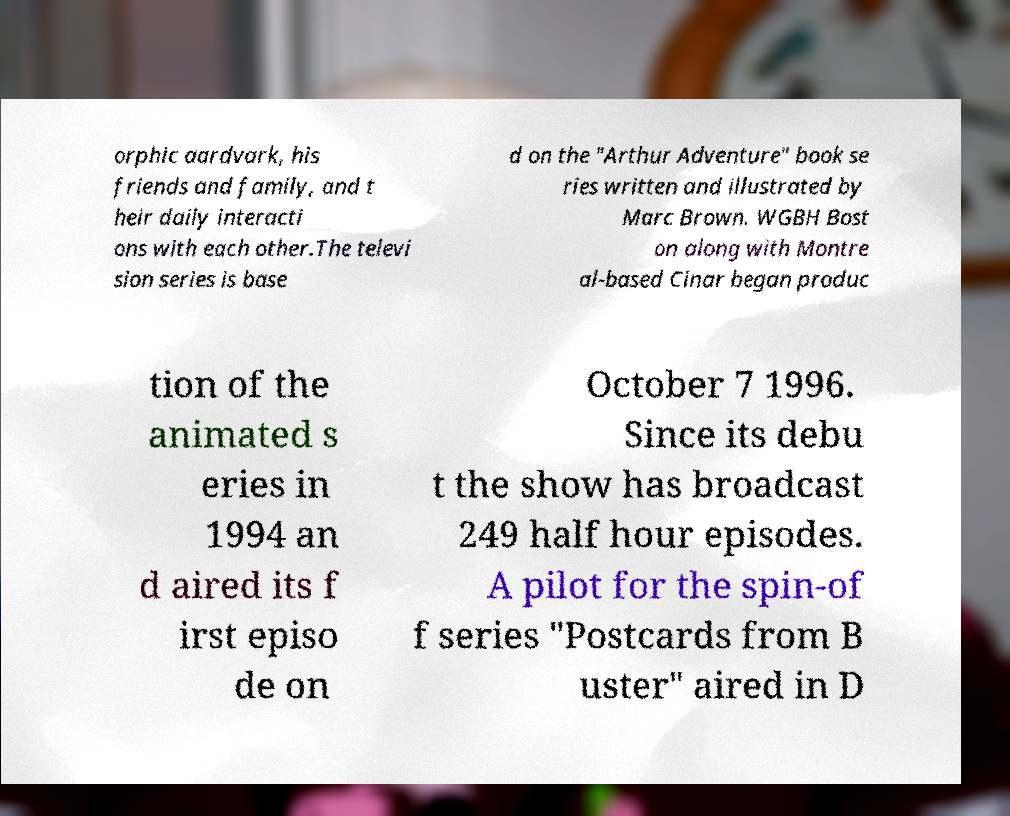Can you accurately transcribe the text from the provided image for me? orphic aardvark, his friends and family, and t heir daily interacti ons with each other.The televi sion series is base d on the "Arthur Adventure" book se ries written and illustrated by Marc Brown. WGBH Bost on along with Montre al-based Cinar began produc tion of the animated s eries in 1994 an d aired its f irst episo de on October 7 1996. Since its debu t the show has broadcast 249 half hour episodes. A pilot for the spin-of f series "Postcards from B uster" aired in D 